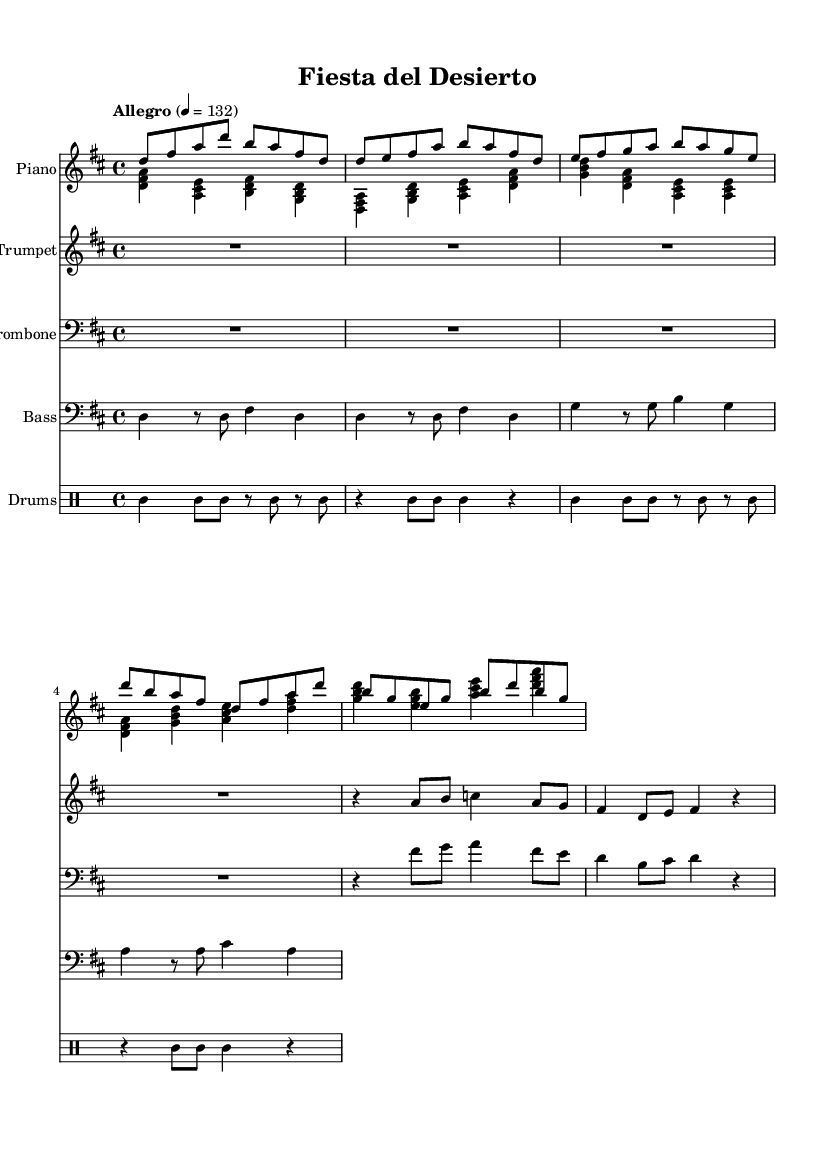What is the key signature of this music? The key signature is indicated at the beginning of the staff and shows two sharps, which correspond to the notes F# and C#. This means the piece is in D major.
Answer: D major What is the time signature of the piece? The time signature is found at the beginning of the sheet music. It is shown as a fraction with a 4 on top and a 4 on the bottom, which indicates that there are four beats in each measure, and the quarter note gets one beat.
Answer: 4/4 What is the tempo marking for this piece? The tempo marking is specified in the sheet music and indicates the speed at which the music should be played. In this case, it states "Allegro" and a metronome marking of 132, which means it should be played at a lively pace.
Answer: Allegro, 132 How many instruments are written in the score? By examining the score layout, we can count the distinct instruments represented. In this case, there are five parts: Piano, Trumpet, Trombone, Bass, and Drums, totaling five instruments.
Answer: Five What is the primary rhythm pattern used in the drums? The drumming section features a repetitive two-bar pattern characterized by a combination of quarter notes and eighth notes with syncopated accents. This implies a rhythmic style typical in Latin music.
Answer: Clave pattern What kind of musical sections are included in the piece? By observing the flow of the notes and the labels, we can identify sections such as the Intro, Verse, and Chorus. This format is common in popular dance music, allowing for a structured yet dynamic performance.
Answer: Intro, Verse, Chorus What style of music does this sheet represent? The characteristics of the music, including the rhythms and instrumentation (like piano, trumpet, and percussion), along with the upbeat tempo, suggest that the style is suited for festive occasions, specifically indicative of Latin dance music.
Answer: Latin dance music 